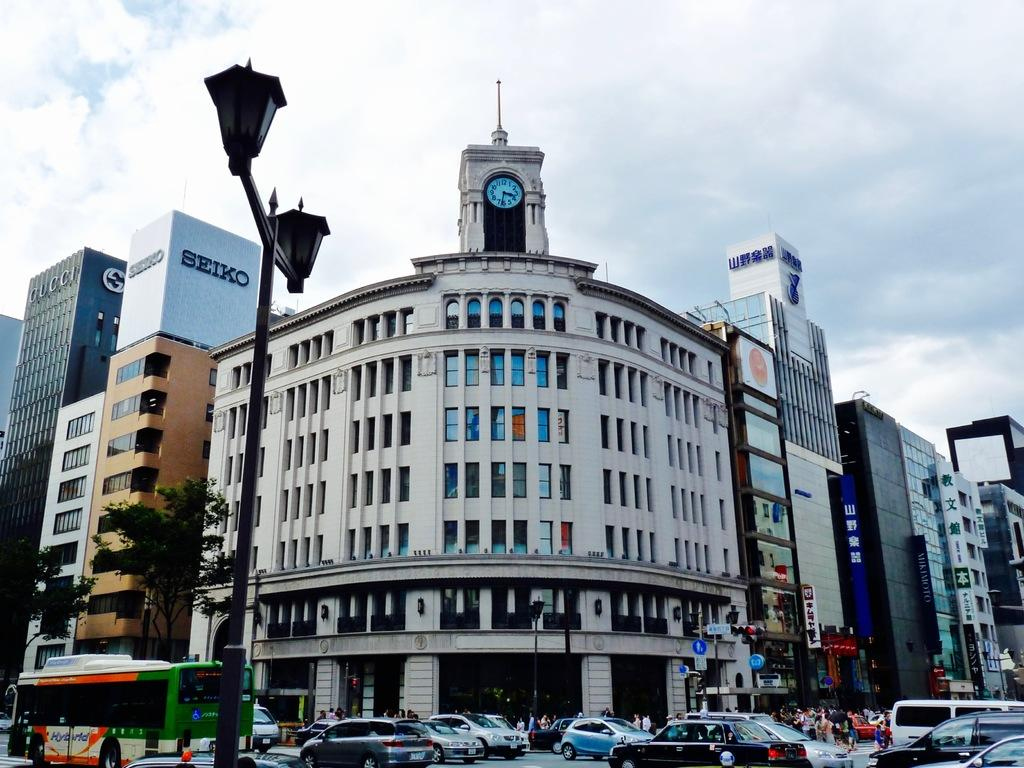What type of structures can be seen in the image? There are buildings in the image. What other natural elements are present in the image? There are trees in the image. Are there any vehicles visible in the image? Yes, there are cars in the image. What is the object in the front of the image? There is a light pole in the front of the image. How would you describe the weather in the image? The sky is cloudy in the image. How many eggs are being twisted by the straw in the image? There are no eggs, twist, or straw present in the image. 